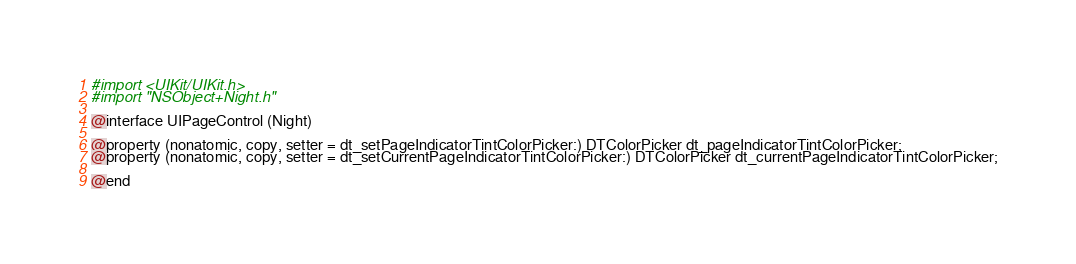Convert code to text. <code><loc_0><loc_0><loc_500><loc_500><_C_>
#import <UIKit/UIKit.h>
#import "NSObject+Night.h"

@interface UIPageControl (Night)

@property (nonatomic, copy, setter = dt_setPageIndicatorTintColorPicker:) DTColorPicker dt_pageIndicatorTintColorPicker;
@property (nonatomic, copy, setter = dt_setCurrentPageIndicatorTintColorPicker:) DTColorPicker dt_currentPageIndicatorTintColorPicker;

@end
</code> 